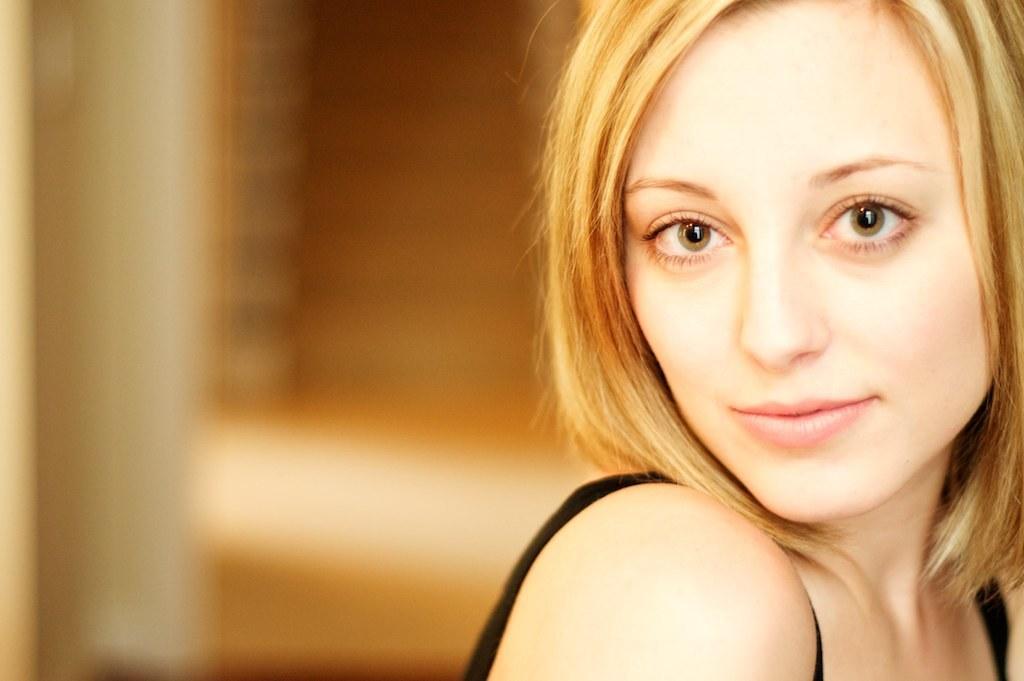Please provide a concise description of this image. In this picture I can observe a woman on the right side. There is yellow color hair on her head. The woman is smiling. The background is completely blurred. 